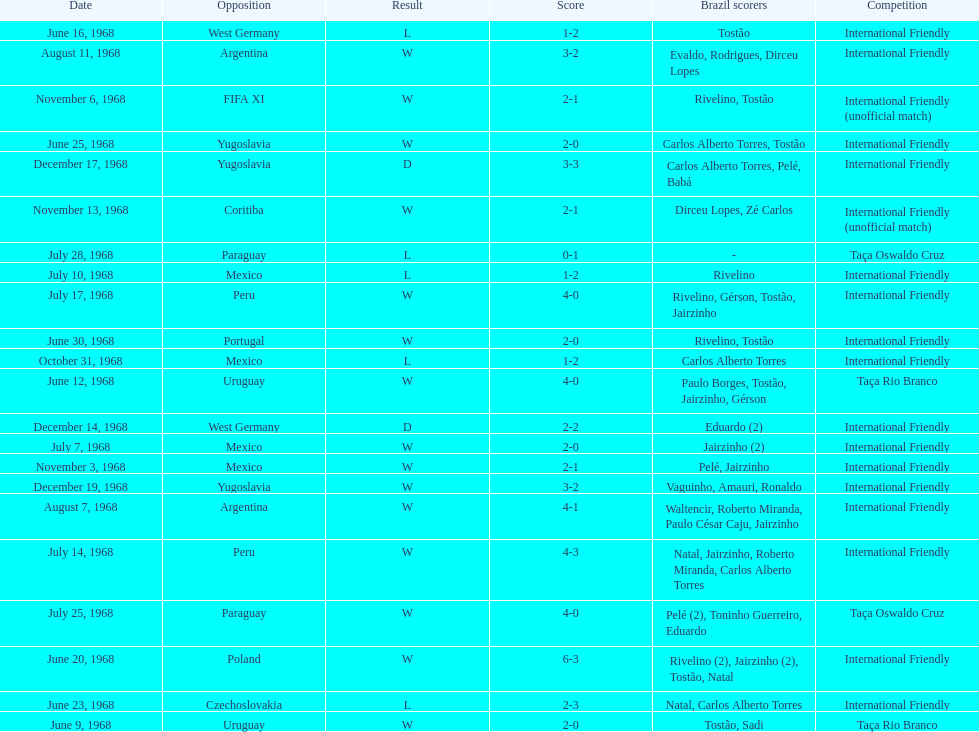Number of losses 5. 